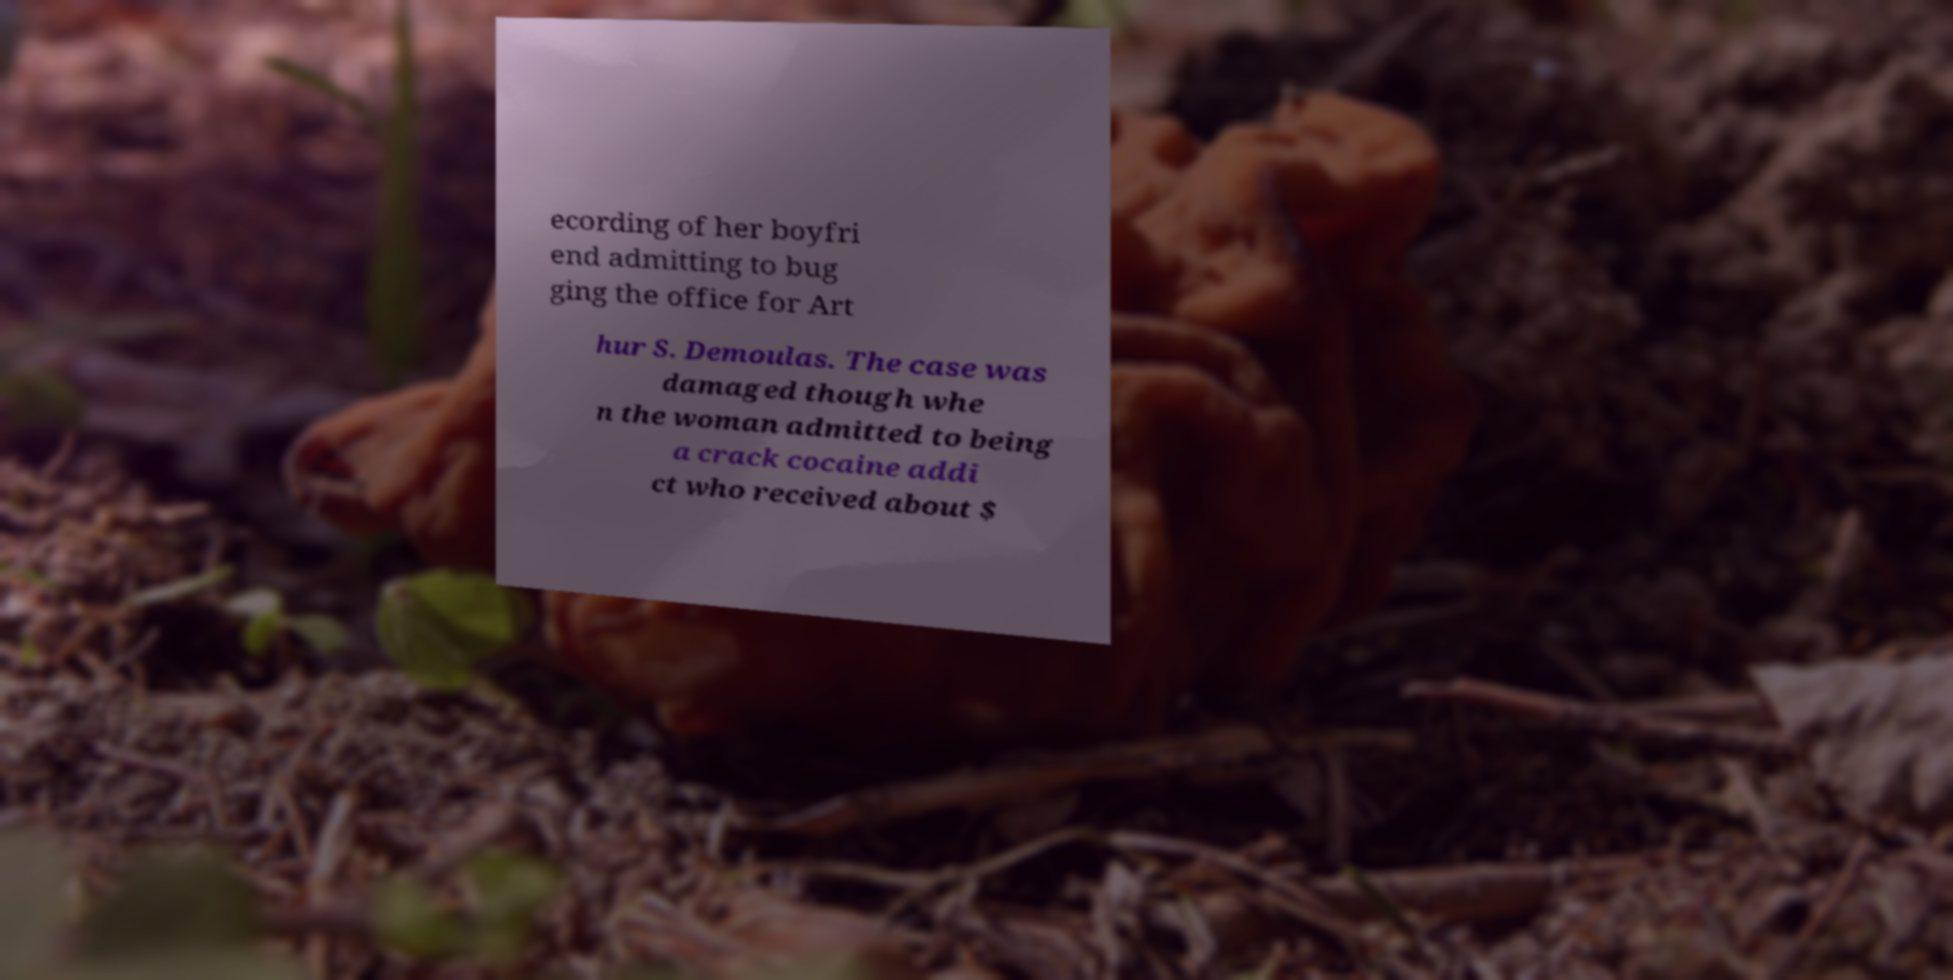Could you assist in decoding the text presented in this image and type it out clearly? ecording of her boyfri end admitting to bug ging the office for Art hur S. Demoulas. The case was damaged though whe n the woman admitted to being a crack cocaine addi ct who received about $ 